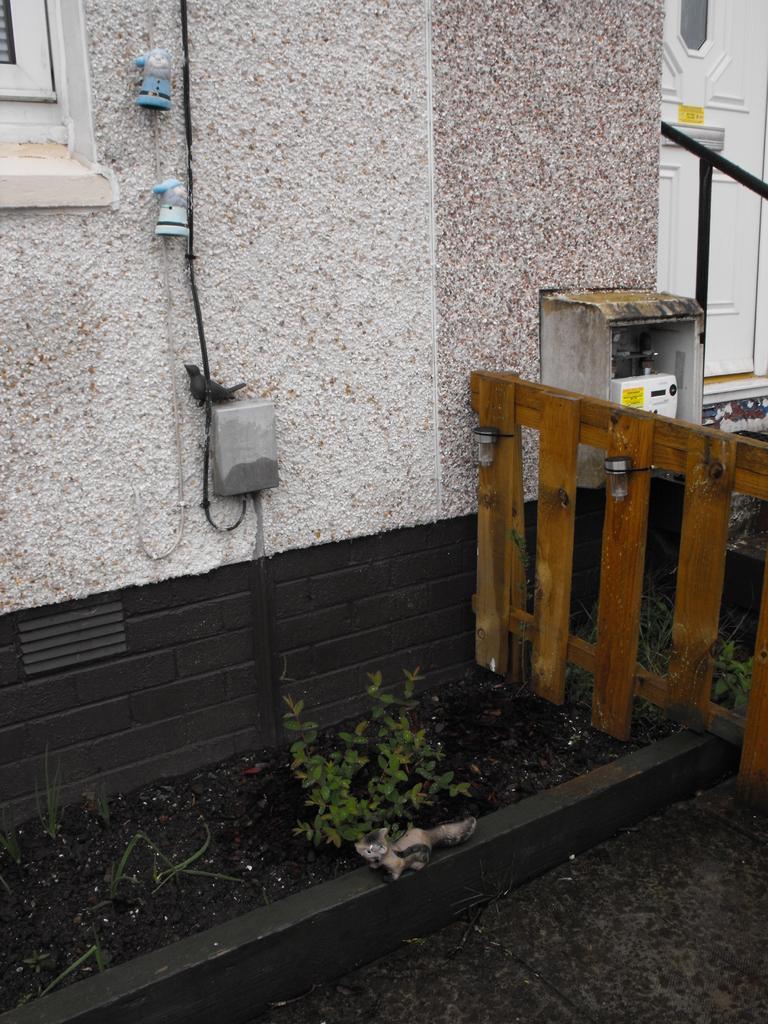Please provide a concise description of this image. In this image, we can see a plant in front of the wall. There is a wooden fence on the right side of the image. There is a box on the wall. 